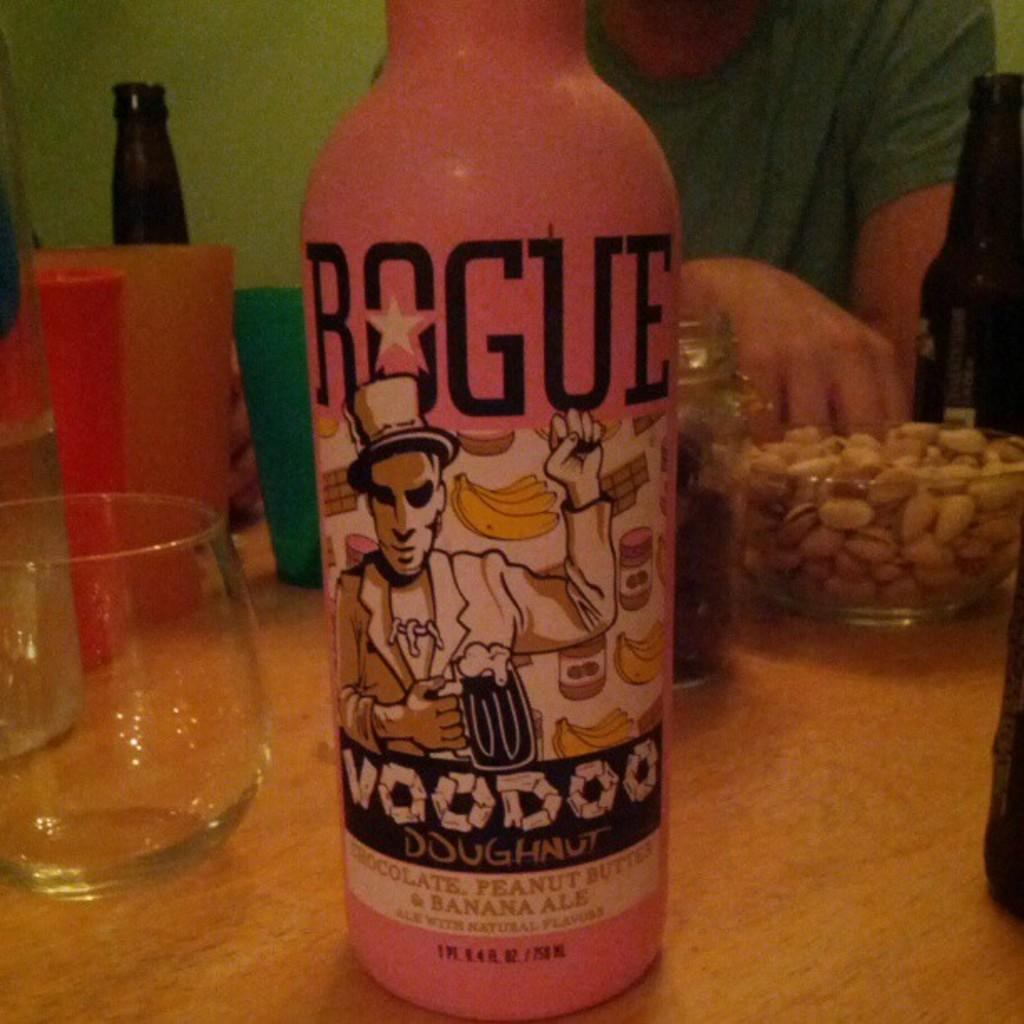<image>
Offer a succinct explanation of the picture presented. A pink bottle says Voodoo on it and has a man in a hat as well. 